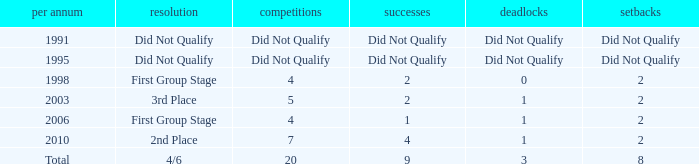How many draws were there in 2006? 1.0. 